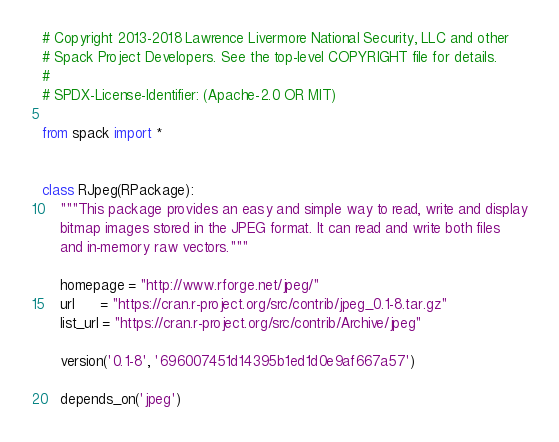Convert code to text. <code><loc_0><loc_0><loc_500><loc_500><_Python_># Copyright 2013-2018 Lawrence Livermore National Security, LLC and other
# Spack Project Developers. See the top-level COPYRIGHT file for details.
#
# SPDX-License-Identifier: (Apache-2.0 OR MIT)

from spack import *


class RJpeg(RPackage):
    """This package provides an easy and simple way to read, write and display
    bitmap images stored in the JPEG format. It can read and write both files
    and in-memory raw vectors."""

    homepage = "http://www.rforge.net/jpeg/"
    url      = "https://cran.r-project.org/src/contrib/jpeg_0.1-8.tar.gz"
    list_url = "https://cran.r-project.org/src/contrib/Archive/jpeg"

    version('0.1-8', '696007451d14395b1ed1d0e9af667a57')

    depends_on('jpeg')
</code> 